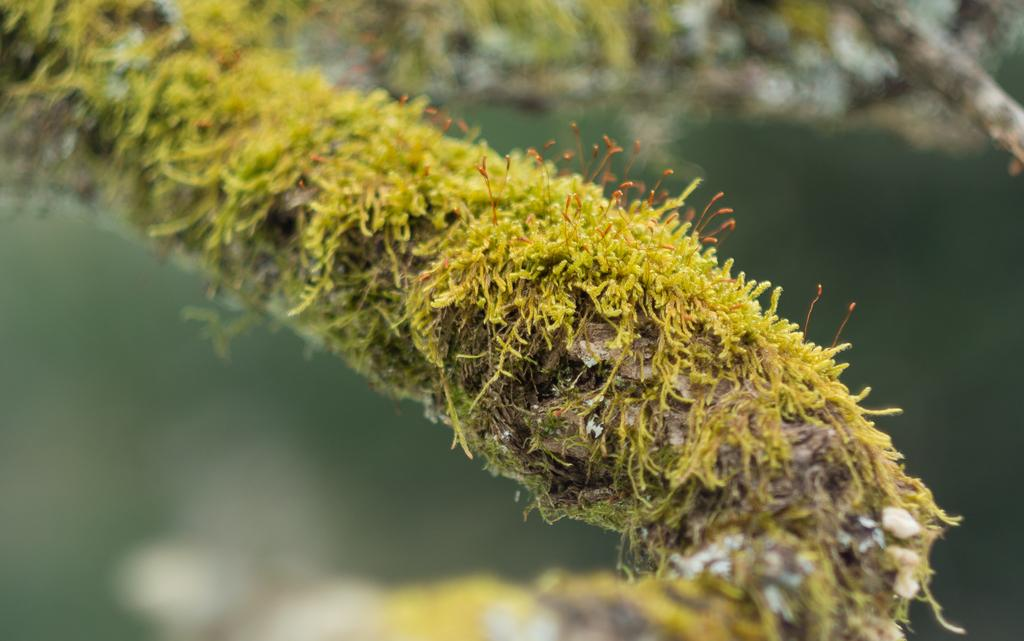What is present in the image? There is a plant in the image. What color is the plant? The plant is green in color. Can you describe the background of the image? The background of the image is blurred. What type of treatment is the plant receiving in the image? There is no indication in the image that the plant is receiving any treatment. 